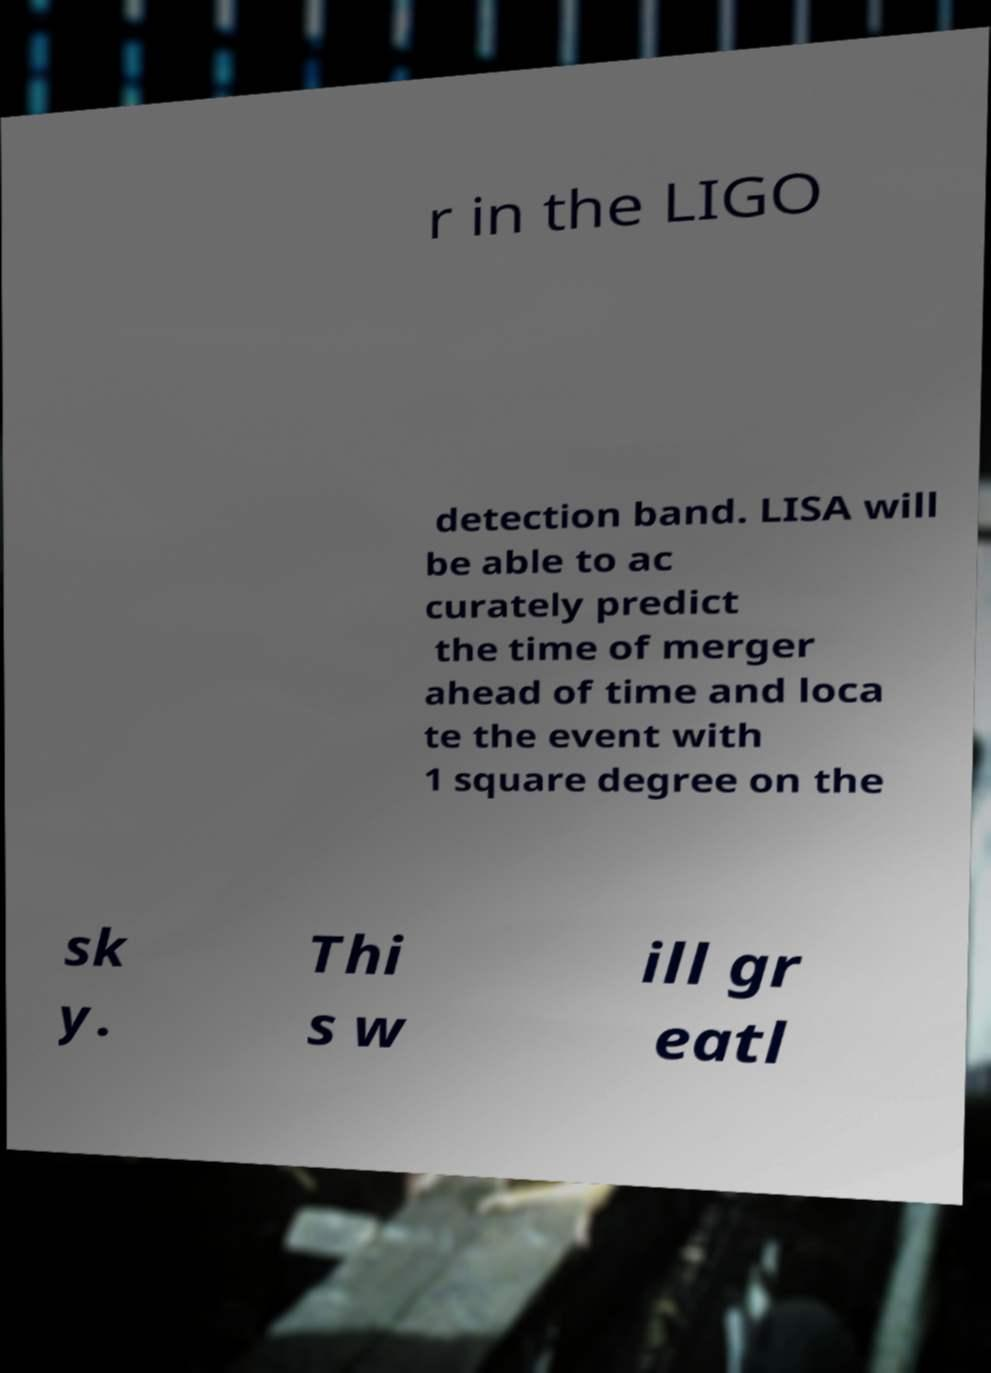There's text embedded in this image that I need extracted. Can you transcribe it verbatim? r in the LIGO detection band. LISA will be able to ac curately predict the time of merger ahead of time and loca te the event with 1 square degree on the sk y. Thi s w ill gr eatl 